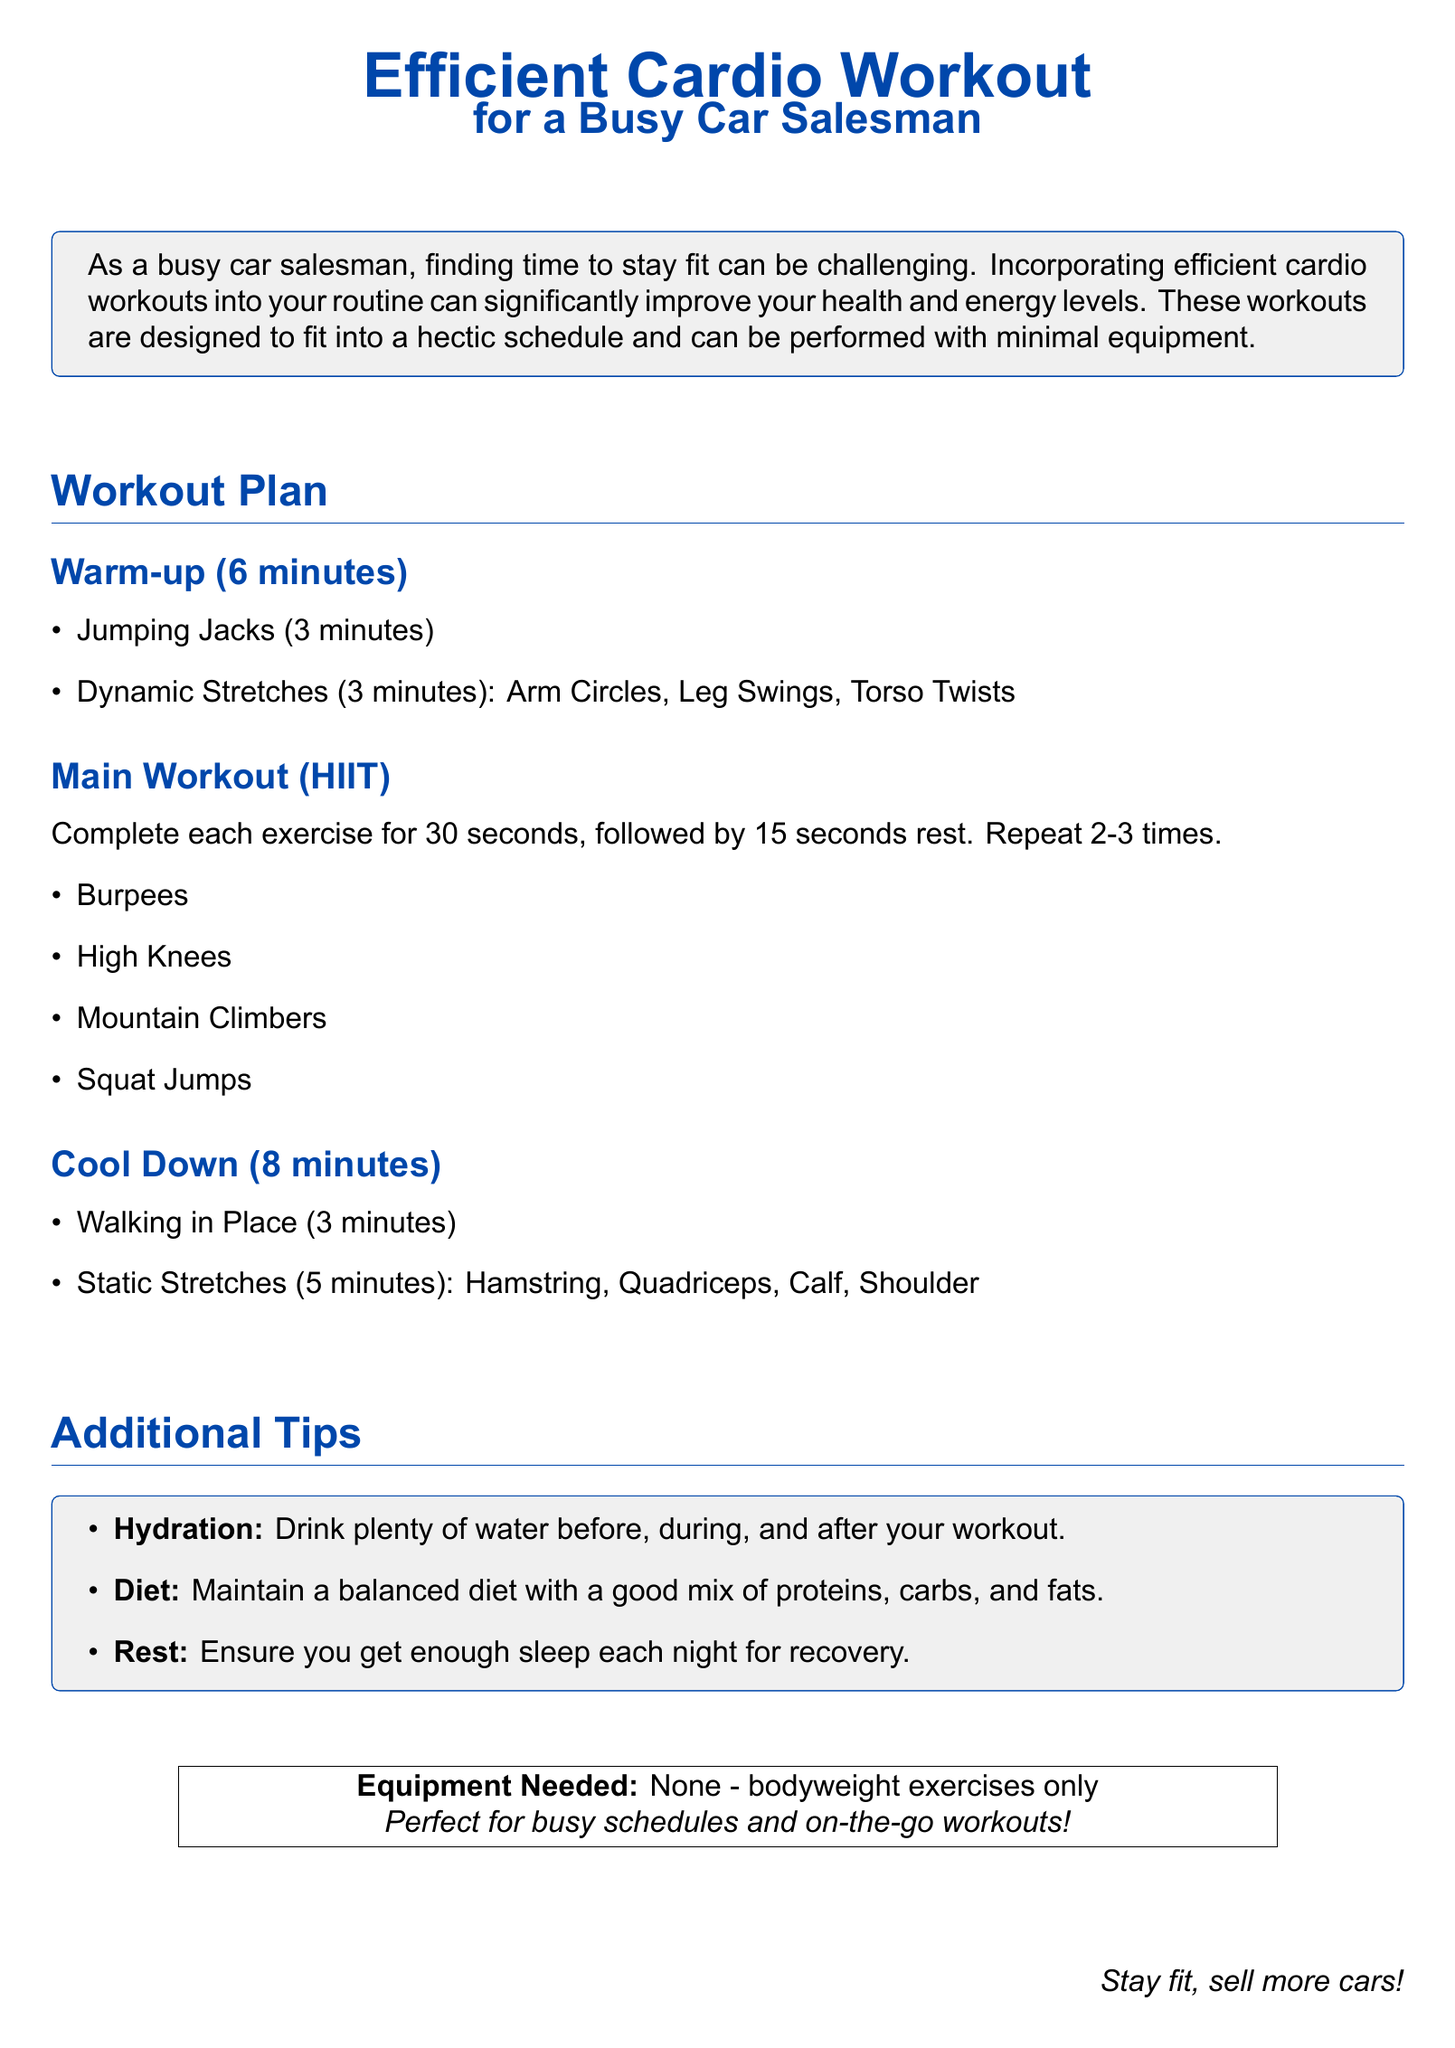What is the title of the workout plan? The title is explicitly stated at the top of the document.
Answer: Efficient Cardio Workout for a Busy Car Salesman How long is the warm-up? The document lists the duration of the warm-up at the beginning of that section.
Answer: 6 minutes What type of workout does the main section focus on? The main workout type is defined in the section header of the workout plan.
Answer: HIIT How long should each exercise in the main workout be performed? The document specifies the duration for each exercise and the rest period.
Answer: 30 seconds What is included in the cool down? The cool down section lists the activities to be performed after the workout.
Answer: Walking in Place, Static Stretches What should you maintain for a balanced diet? The additional tips suggest key components to include in a balanced diet.
Answer: Proteins, carbs, and fats How many times should the main exercises be repeated? The document clearly states how many repetitions are recommended.
Answer: 2-3 times What is the main benefit of these workouts mentioned? The introduction provides the primary advantage of incorporating these workouts.
Answer: Improve your health and energy levels What type of equipment is needed for the workout? The document notes the equipment requirements in the final section.
Answer: None - bodyweight exercises only What is advised for hydration? The additional tips specifically highlight hydration recommendations.
Answer: Drink plenty of water 